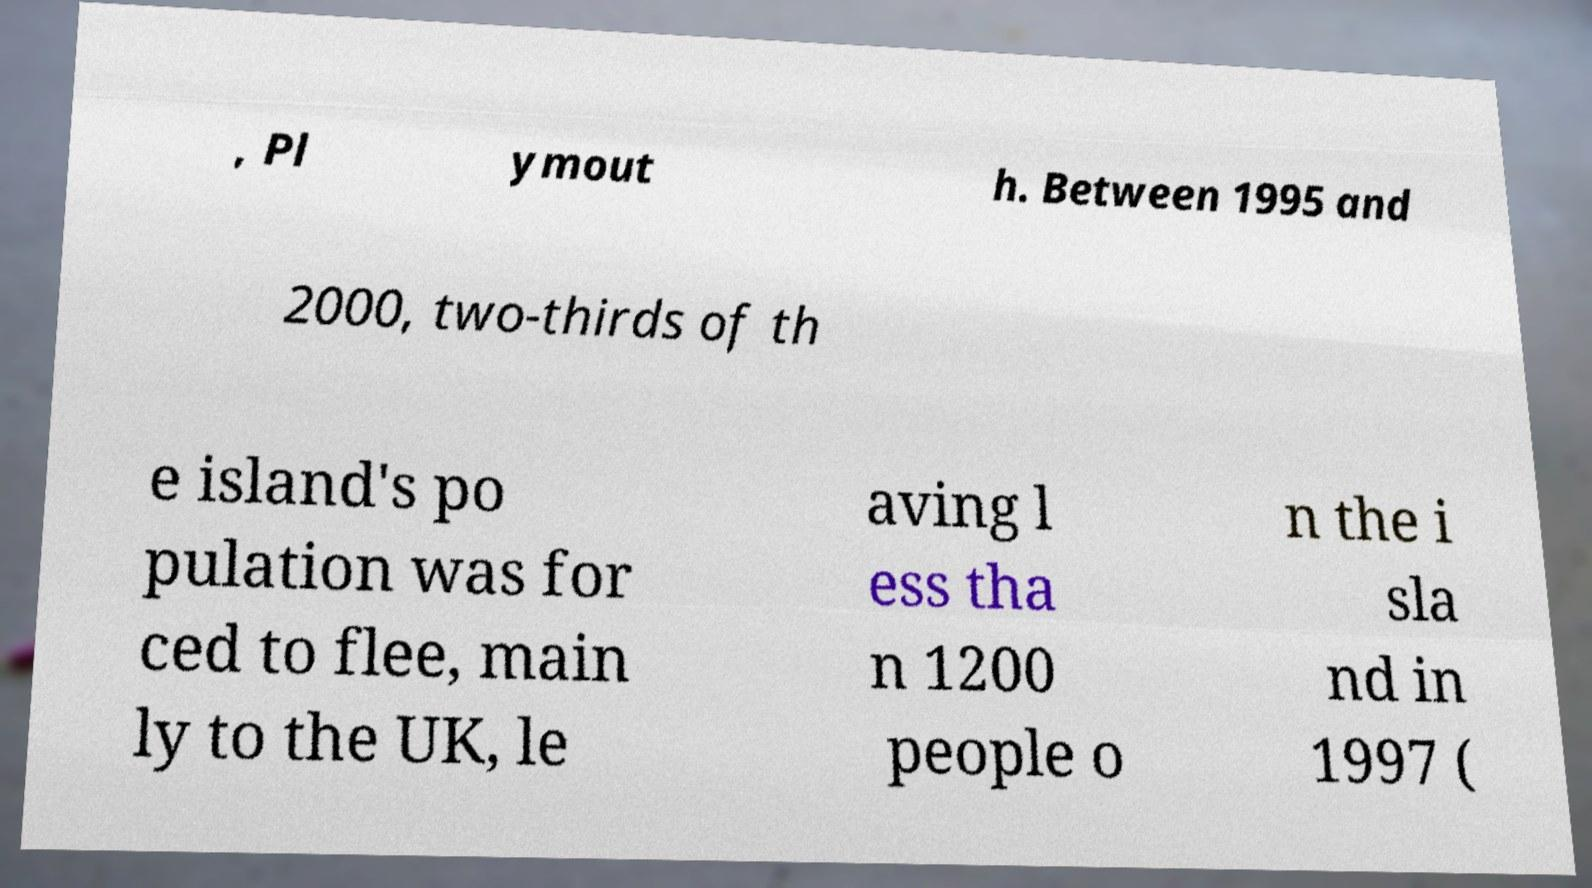For documentation purposes, I need the text within this image transcribed. Could you provide that? , Pl ymout h. Between 1995 and 2000, two-thirds of th e island's po pulation was for ced to flee, main ly to the UK, le aving l ess tha n 1200 people o n the i sla nd in 1997 ( 